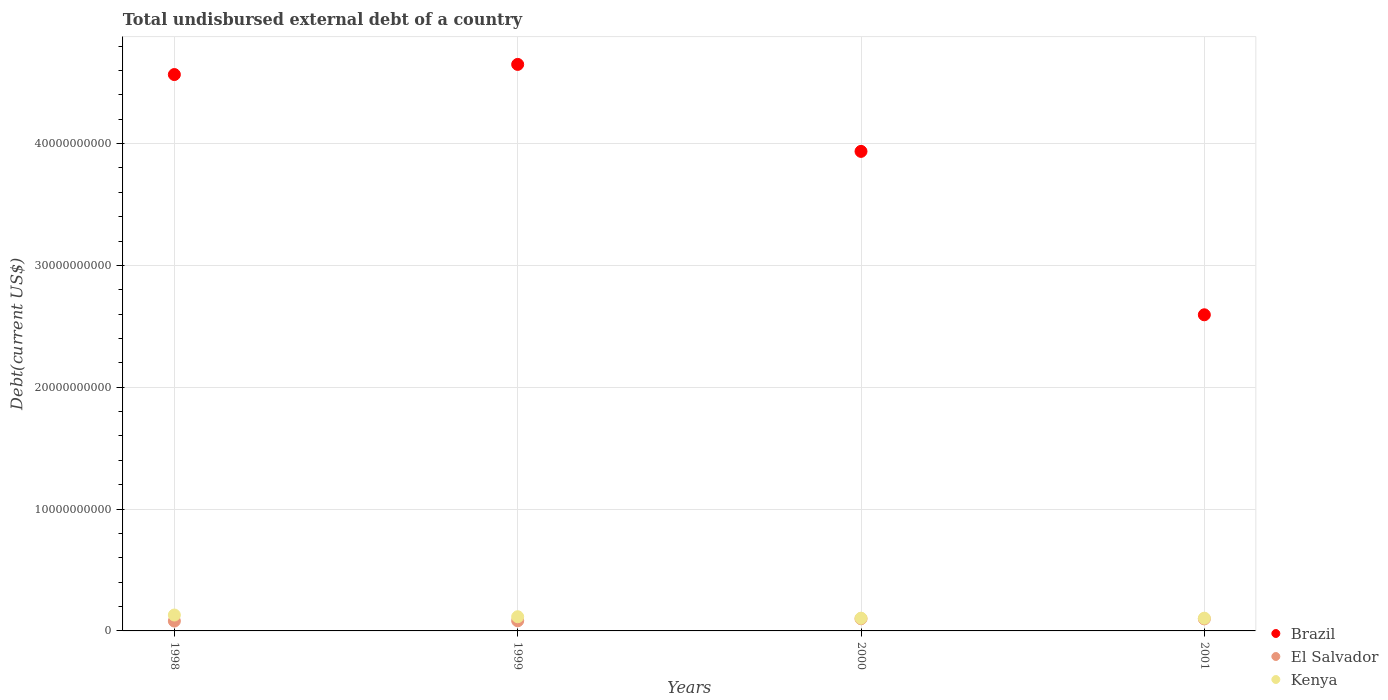How many different coloured dotlines are there?
Offer a very short reply. 3. Is the number of dotlines equal to the number of legend labels?
Offer a very short reply. Yes. What is the total undisbursed external debt in El Salvador in 2001?
Your answer should be compact. 9.88e+08. Across all years, what is the maximum total undisbursed external debt in Kenya?
Your answer should be compact. 1.30e+09. Across all years, what is the minimum total undisbursed external debt in El Salvador?
Make the answer very short. 8.10e+08. In which year was the total undisbursed external debt in El Salvador maximum?
Your answer should be very brief. 2000. What is the total total undisbursed external debt in Brazil in the graph?
Provide a succinct answer. 1.57e+11. What is the difference between the total undisbursed external debt in Brazil in 1998 and that in 1999?
Provide a succinct answer. -8.32e+08. What is the difference between the total undisbursed external debt in Brazil in 1998 and the total undisbursed external debt in El Salvador in 2000?
Your response must be concise. 4.47e+1. What is the average total undisbursed external debt in Kenya per year?
Give a very brief answer. 1.14e+09. In the year 1999, what is the difference between the total undisbursed external debt in El Salvador and total undisbursed external debt in Kenya?
Provide a short and direct response. -3.32e+08. What is the ratio of the total undisbursed external debt in Brazil in 1999 to that in 2000?
Your response must be concise. 1.18. What is the difference between the highest and the second highest total undisbursed external debt in El Salvador?
Give a very brief answer. 1.06e+07. What is the difference between the highest and the lowest total undisbursed external debt in Brazil?
Make the answer very short. 2.06e+1. In how many years, is the total undisbursed external debt in Brazil greater than the average total undisbursed external debt in Brazil taken over all years?
Your answer should be compact. 2. Is it the case that in every year, the sum of the total undisbursed external debt in Brazil and total undisbursed external debt in Kenya  is greater than the total undisbursed external debt in El Salvador?
Make the answer very short. Yes. Is the total undisbursed external debt in Brazil strictly greater than the total undisbursed external debt in El Salvador over the years?
Your response must be concise. Yes. Is the total undisbursed external debt in El Salvador strictly less than the total undisbursed external debt in Brazil over the years?
Provide a succinct answer. Yes. How many legend labels are there?
Your response must be concise. 3. What is the title of the graph?
Offer a terse response. Total undisbursed external debt of a country. Does "Bahamas" appear as one of the legend labels in the graph?
Make the answer very short. No. What is the label or title of the Y-axis?
Provide a short and direct response. Debt(current US$). What is the Debt(current US$) in Brazil in 1998?
Your answer should be compact. 4.57e+1. What is the Debt(current US$) of El Salvador in 1998?
Ensure brevity in your answer.  8.10e+08. What is the Debt(current US$) in Kenya in 1998?
Keep it short and to the point. 1.30e+09. What is the Debt(current US$) of Brazil in 1999?
Your answer should be very brief. 4.65e+1. What is the Debt(current US$) in El Salvador in 1999?
Offer a terse response. 8.32e+08. What is the Debt(current US$) of Kenya in 1999?
Your response must be concise. 1.16e+09. What is the Debt(current US$) of Brazil in 2000?
Provide a succinct answer. 3.94e+1. What is the Debt(current US$) of El Salvador in 2000?
Offer a very short reply. 9.99e+08. What is the Debt(current US$) of Kenya in 2000?
Provide a short and direct response. 1.04e+09. What is the Debt(current US$) of Brazil in 2001?
Your answer should be very brief. 2.59e+1. What is the Debt(current US$) of El Salvador in 2001?
Offer a very short reply. 9.88e+08. What is the Debt(current US$) of Kenya in 2001?
Give a very brief answer. 1.04e+09. Across all years, what is the maximum Debt(current US$) in Brazil?
Your answer should be very brief. 4.65e+1. Across all years, what is the maximum Debt(current US$) of El Salvador?
Give a very brief answer. 9.99e+08. Across all years, what is the maximum Debt(current US$) in Kenya?
Provide a short and direct response. 1.30e+09. Across all years, what is the minimum Debt(current US$) in Brazil?
Provide a succinct answer. 2.59e+1. Across all years, what is the minimum Debt(current US$) of El Salvador?
Give a very brief answer. 8.10e+08. Across all years, what is the minimum Debt(current US$) of Kenya?
Give a very brief answer. 1.04e+09. What is the total Debt(current US$) in Brazil in the graph?
Offer a very short reply. 1.57e+11. What is the total Debt(current US$) in El Salvador in the graph?
Your response must be concise. 3.63e+09. What is the total Debt(current US$) in Kenya in the graph?
Keep it short and to the point. 4.56e+09. What is the difference between the Debt(current US$) of Brazil in 1998 and that in 1999?
Give a very brief answer. -8.32e+08. What is the difference between the Debt(current US$) in El Salvador in 1998 and that in 1999?
Keep it short and to the point. -2.27e+07. What is the difference between the Debt(current US$) in Kenya in 1998 and that in 1999?
Offer a very short reply. 1.40e+08. What is the difference between the Debt(current US$) in Brazil in 1998 and that in 2000?
Make the answer very short. 6.31e+09. What is the difference between the Debt(current US$) in El Salvador in 1998 and that in 2000?
Your answer should be very brief. -1.89e+08. What is the difference between the Debt(current US$) in Kenya in 1998 and that in 2000?
Offer a terse response. 2.62e+08. What is the difference between the Debt(current US$) in Brazil in 1998 and that in 2001?
Your answer should be very brief. 1.97e+1. What is the difference between the Debt(current US$) of El Salvador in 1998 and that in 2001?
Provide a short and direct response. -1.78e+08. What is the difference between the Debt(current US$) of Kenya in 1998 and that in 2001?
Offer a very short reply. 2.60e+08. What is the difference between the Debt(current US$) of Brazil in 1999 and that in 2000?
Ensure brevity in your answer.  7.14e+09. What is the difference between the Debt(current US$) of El Salvador in 1999 and that in 2000?
Make the answer very short. -1.66e+08. What is the difference between the Debt(current US$) in Kenya in 1999 and that in 2000?
Ensure brevity in your answer.  1.21e+08. What is the difference between the Debt(current US$) in Brazil in 1999 and that in 2001?
Ensure brevity in your answer.  2.06e+1. What is the difference between the Debt(current US$) in El Salvador in 1999 and that in 2001?
Provide a succinct answer. -1.56e+08. What is the difference between the Debt(current US$) of Kenya in 1999 and that in 2001?
Ensure brevity in your answer.  1.19e+08. What is the difference between the Debt(current US$) in Brazil in 2000 and that in 2001?
Your response must be concise. 1.34e+1. What is the difference between the Debt(current US$) in El Salvador in 2000 and that in 2001?
Your answer should be compact. 1.06e+07. What is the difference between the Debt(current US$) of Kenya in 2000 and that in 2001?
Make the answer very short. -1.93e+06. What is the difference between the Debt(current US$) of Brazil in 1998 and the Debt(current US$) of El Salvador in 1999?
Your answer should be compact. 4.48e+1. What is the difference between the Debt(current US$) of Brazil in 1998 and the Debt(current US$) of Kenya in 1999?
Your answer should be compact. 4.45e+1. What is the difference between the Debt(current US$) of El Salvador in 1998 and the Debt(current US$) of Kenya in 1999?
Give a very brief answer. -3.54e+08. What is the difference between the Debt(current US$) of Brazil in 1998 and the Debt(current US$) of El Salvador in 2000?
Provide a short and direct response. 4.47e+1. What is the difference between the Debt(current US$) in Brazil in 1998 and the Debt(current US$) in Kenya in 2000?
Provide a short and direct response. 4.46e+1. What is the difference between the Debt(current US$) in El Salvador in 1998 and the Debt(current US$) in Kenya in 2000?
Your answer should be very brief. -2.33e+08. What is the difference between the Debt(current US$) in Brazil in 1998 and the Debt(current US$) in El Salvador in 2001?
Make the answer very short. 4.47e+1. What is the difference between the Debt(current US$) of Brazil in 1998 and the Debt(current US$) of Kenya in 2001?
Provide a succinct answer. 4.46e+1. What is the difference between the Debt(current US$) of El Salvador in 1998 and the Debt(current US$) of Kenya in 2001?
Make the answer very short. -2.35e+08. What is the difference between the Debt(current US$) in Brazil in 1999 and the Debt(current US$) in El Salvador in 2000?
Offer a very short reply. 4.55e+1. What is the difference between the Debt(current US$) of Brazil in 1999 and the Debt(current US$) of Kenya in 2000?
Your answer should be very brief. 4.55e+1. What is the difference between the Debt(current US$) in El Salvador in 1999 and the Debt(current US$) in Kenya in 2000?
Offer a terse response. -2.11e+08. What is the difference between the Debt(current US$) in Brazil in 1999 and the Debt(current US$) in El Salvador in 2001?
Keep it short and to the point. 4.55e+1. What is the difference between the Debt(current US$) of Brazil in 1999 and the Debt(current US$) of Kenya in 2001?
Keep it short and to the point. 4.55e+1. What is the difference between the Debt(current US$) of El Salvador in 1999 and the Debt(current US$) of Kenya in 2001?
Your answer should be very brief. -2.12e+08. What is the difference between the Debt(current US$) in Brazil in 2000 and the Debt(current US$) in El Salvador in 2001?
Offer a very short reply. 3.84e+1. What is the difference between the Debt(current US$) of Brazil in 2000 and the Debt(current US$) of Kenya in 2001?
Provide a short and direct response. 3.83e+1. What is the difference between the Debt(current US$) of El Salvador in 2000 and the Debt(current US$) of Kenya in 2001?
Offer a very short reply. -4.63e+07. What is the average Debt(current US$) in Brazil per year?
Your answer should be compact. 3.94e+1. What is the average Debt(current US$) of El Salvador per year?
Offer a very short reply. 9.07e+08. What is the average Debt(current US$) in Kenya per year?
Make the answer very short. 1.14e+09. In the year 1998, what is the difference between the Debt(current US$) of Brazil and Debt(current US$) of El Salvador?
Make the answer very short. 4.49e+1. In the year 1998, what is the difference between the Debt(current US$) of Brazil and Debt(current US$) of Kenya?
Offer a very short reply. 4.44e+1. In the year 1998, what is the difference between the Debt(current US$) of El Salvador and Debt(current US$) of Kenya?
Keep it short and to the point. -4.95e+08. In the year 1999, what is the difference between the Debt(current US$) of Brazil and Debt(current US$) of El Salvador?
Offer a terse response. 4.57e+1. In the year 1999, what is the difference between the Debt(current US$) of Brazil and Debt(current US$) of Kenya?
Keep it short and to the point. 4.53e+1. In the year 1999, what is the difference between the Debt(current US$) of El Salvador and Debt(current US$) of Kenya?
Keep it short and to the point. -3.32e+08. In the year 2000, what is the difference between the Debt(current US$) in Brazil and Debt(current US$) in El Salvador?
Give a very brief answer. 3.84e+1. In the year 2000, what is the difference between the Debt(current US$) of Brazil and Debt(current US$) of Kenya?
Offer a very short reply. 3.83e+1. In the year 2000, what is the difference between the Debt(current US$) of El Salvador and Debt(current US$) of Kenya?
Give a very brief answer. -4.43e+07. In the year 2001, what is the difference between the Debt(current US$) of Brazil and Debt(current US$) of El Salvador?
Provide a succinct answer. 2.50e+1. In the year 2001, what is the difference between the Debt(current US$) in Brazil and Debt(current US$) in Kenya?
Provide a succinct answer. 2.49e+1. In the year 2001, what is the difference between the Debt(current US$) in El Salvador and Debt(current US$) in Kenya?
Your answer should be compact. -5.68e+07. What is the ratio of the Debt(current US$) of Brazil in 1998 to that in 1999?
Provide a succinct answer. 0.98. What is the ratio of the Debt(current US$) of El Salvador in 1998 to that in 1999?
Your answer should be very brief. 0.97. What is the ratio of the Debt(current US$) of Kenya in 1998 to that in 1999?
Ensure brevity in your answer.  1.12. What is the ratio of the Debt(current US$) in Brazil in 1998 to that in 2000?
Give a very brief answer. 1.16. What is the ratio of the Debt(current US$) in El Salvador in 1998 to that in 2000?
Make the answer very short. 0.81. What is the ratio of the Debt(current US$) of Kenya in 1998 to that in 2000?
Make the answer very short. 1.25. What is the ratio of the Debt(current US$) in Brazil in 1998 to that in 2001?
Your response must be concise. 1.76. What is the ratio of the Debt(current US$) in El Salvador in 1998 to that in 2001?
Your answer should be compact. 0.82. What is the ratio of the Debt(current US$) of Kenya in 1998 to that in 2001?
Ensure brevity in your answer.  1.25. What is the ratio of the Debt(current US$) of Brazil in 1999 to that in 2000?
Make the answer very short. 1.18. What is the ratio of the Debt(current US$) of El Salvador in 1999 to that in 2000?
Keep it short and to the point. 0.83. What is the ratio of the Debt(current US$) in Kenya in 1999 to that in 2000?
Ensure brevity in your answer.  1.12. What is the ratio of the Debt(current US$) in Brazil in 1999 to that in 2001?
Give a very brief answer. 1.79. What is the ratio of the Debt(current US$) of El Salvador in 1999 to that in 2001?
Make the answer very short. 0.84. What is the ratio of the Debt(current US$) of Kenya in 1999 to that in 2001?
Provide a short and direct response. 1.11. What is the ratio of the Debt(current US$) of Brazil in 2000 to that in 2001?
Ensure brevity in your answer.  1.52. What is the ratio of the Debt(current US$) in El Salvador in 2000 to that in 2001?
Give a very brief answer. 1.01. What is the ratio of the Debt(current US$) of Kenya in 2000 to that in 2001?
Your answer should be compact. 1. What is the difference between the highest and the second highest Debt(current US$) in Brazil?
Offer a very short reply. 8.32e+08. What is the difference between the highest and the second highest Debt(current US$) in El Salvador?
Your response must be concise. 1.06e+07. What is the difference between the highest and the second highest Debt(current US$) in Kenya?
Your response must be concise. 1.40e+08. What is the difference between the highest and the lowest Debt(current US$) of Brazil?
Your response must be concise. 2.06e+1. What is the difference between the highest and the lowest Debt(current US$) in El Salvador?
Offer a terse response. 1.89e+08. What is the difference between the highest and the lowest Debt(current US$) in Kenya?
Your response must be concise. 2.62e+08. 